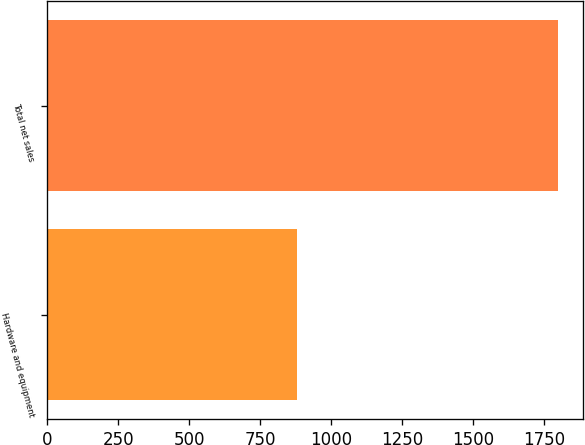<chart> <loc_0><loc_0><loc_500><loc_500><bar_chart><fcel>Hardware and equipment<fcel>Total net sales<nl><fcel>879<fcel>1799<nl></chart> 